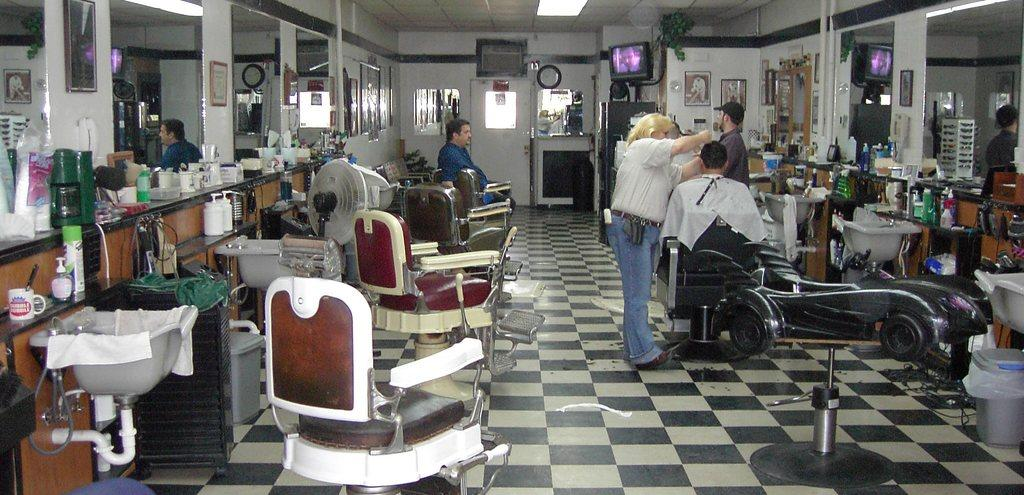What is the color of the wall in the image? The wall in the image is white. What objects in the image can be used for reflection? There are mirrors in the image that can be used for reflection. Who or what can be seen in the image? There are people in the image. What type of openings are present in the image? There are doors in the image. What electronic device is visible in the image? There is a television in the image. What can be used for washing in the image? There is a sink in the image. What type of containers are present in the image? There are bottles in the image. What device can be used for cooling in the image? There is a fan in the image. Where is the cemetery located in the image? There is no cemetery present in the image. What type of pain is being experienced by the people in the image? There is no indication of pain being experienced by the people in the image. 